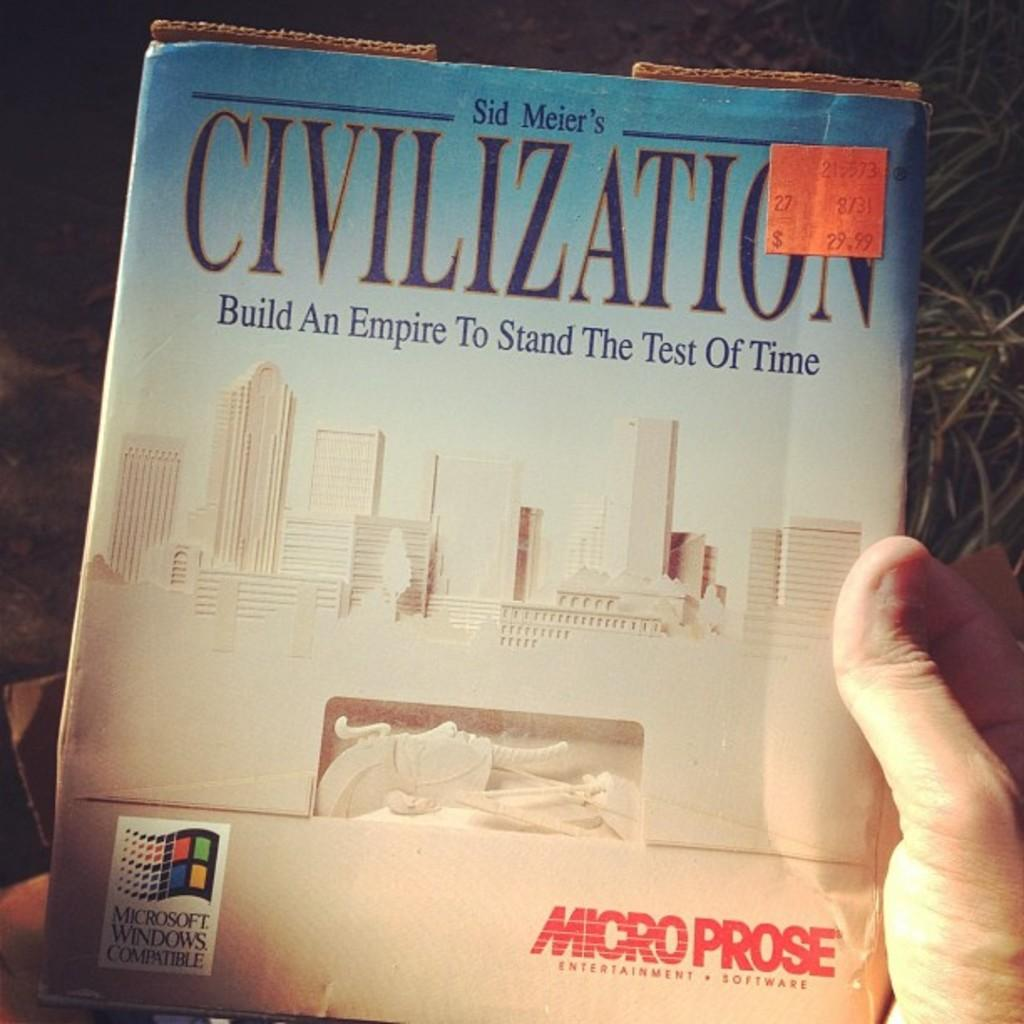<image>
Create a compact narrative representing the image presented. A box for a Microsoft product sits on top of grass 